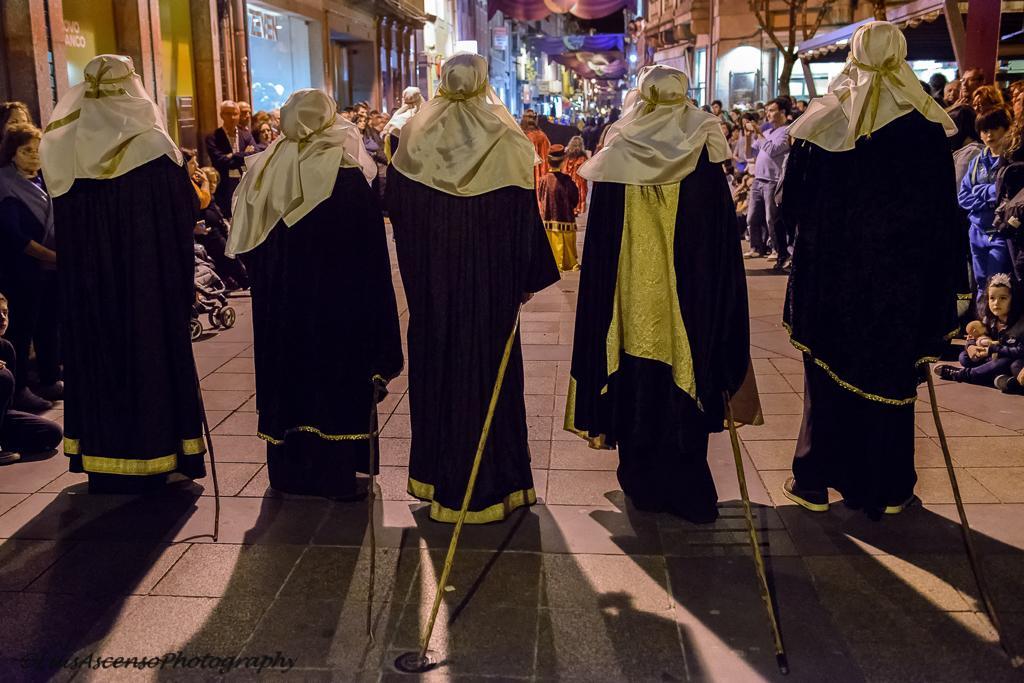Please provide a concise description of this image. There are five people standing in a black and golden dress and a carrying a stick in their hands and there are some people standing at the back and taking a pictures. 